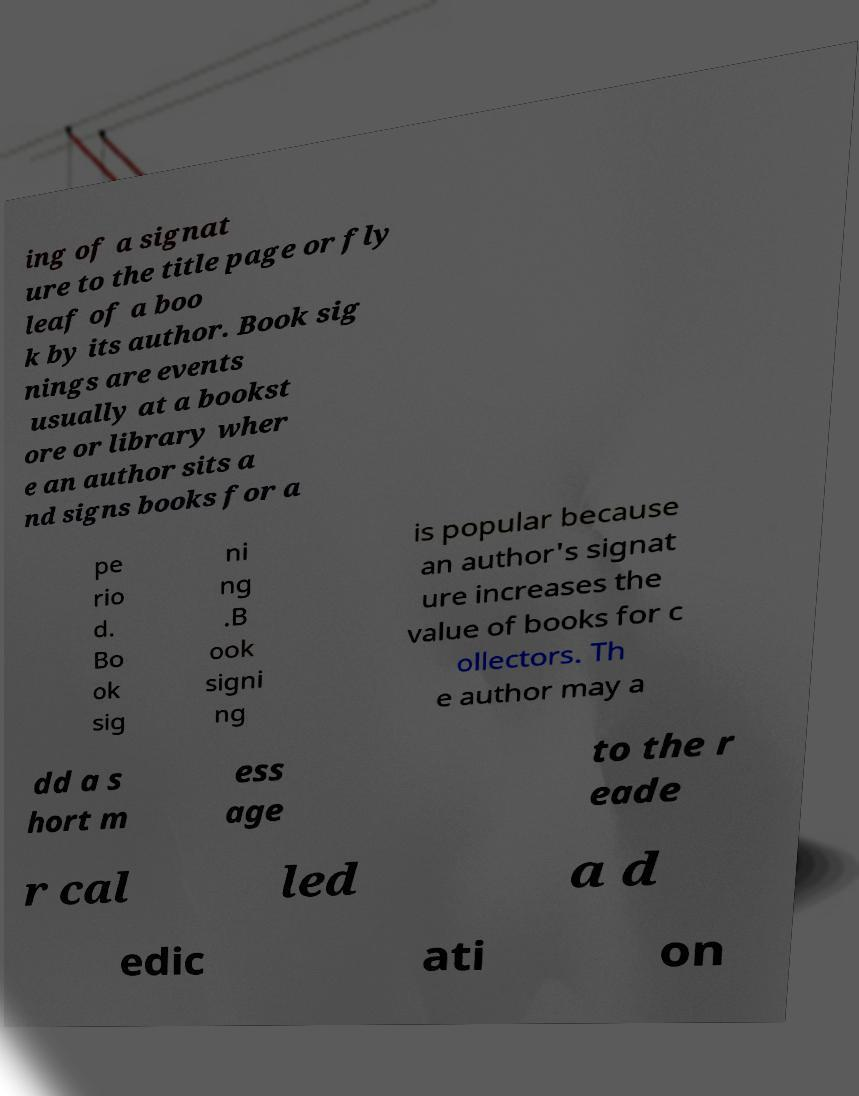Could you assist in decoding the text presented in this image and type it out clearly? ing of a signat ure to the title page or fly leaf of a boo k by its author. Book sig nings are events usually at a bookst ore or library wher e an author sits a nd signs books for a pe rio d. Bo ok sig ni ng .B ook signi ng is popular because an author's signat ure increases the value of books for c ollectors. Th e author may a dd a s hort m ess age to the r eade r cal led a d edic ati on 